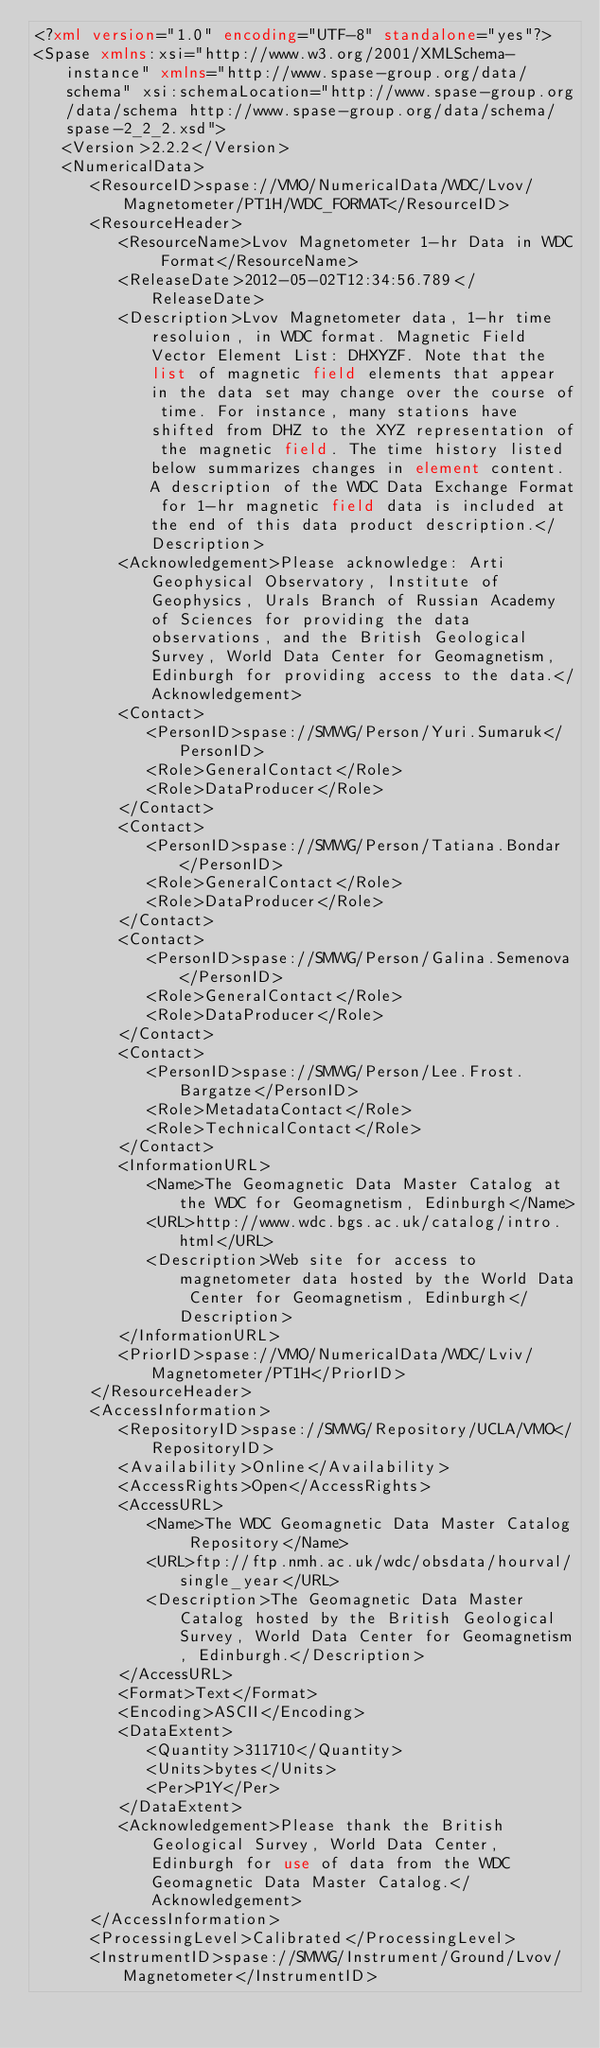<code> <loc_0><loc_0><loc_500><loc_500><_XML_><?xml version="1.0" encoding="UTF-8" standalone="yes"?>
<Spase xmlns:xsi="http://www.w3.org/2001/XMLSchema-instance" xmlns="http://www.spase-group.org/data/schema" xsi:schemaLocation="http://www.spase-group.org/data/schema http://www.spase-group.org/data/schema/spase-2_2_2.xsd">
   <Version>2.2.2</Version>
   <NumericalData>
      <ResourceID>spase://VMO/NumericalData/WDC/Lvov/Magnetometer/PT1H/WDC_FORMAT</ResourceID>
      <ResourceHeader>
         <ResourceName>Lvov Magnetometer 1-hr Data in WDC Format</ResourceName>
         <ReleaseDate>2012-05-02T12:34:56.789</ReleaseDate>
         <Description>Lvov Magnetometer data, 1-hr time resoluion, in WDC format. Magnetic Field Vector Element List: DHXYZF. Note that the list of magnetic field elements that appear in the data set may change over the course of time. For instance, many stations have shifted from DHZ to the XYZ representation of the magnetic field. The time history listed below summarizes changes in element content. A description of the WDC Data Exchange Format for 1-hr magnetic field data is included at the end of this data product description.</Description>
         <Acknowledgement>Please acknowledge: Arti Geophysical Observatory, Institute of Geophysics, Urals Branch of Russian Academy of Sciences for providing the data observations, and the British Geological Survey, World Data Center for Geomagnetism, Edinburgh for providing access to the data.</Acknowledgement>
         <Contact>
            <PersonID>spase://SMWG/Person/Yuri.Sumaruk</PersonID>
            <Role>GeneralContact</Role>
            <Role>DataProducer</Role>
         </Contact>
         <Contact>
            <PersonID>spase://SMWG/Person/Tatiana.Bondar</PersonID>
            <Role>GeneralContact</Role>
            <Role>DataProducer</Role>
         </Contact>
         <Contact>
            <PersonID>spase://SMWG/Person/Galina.Semenova</PersonID>
            <Role>GeneralContact</Role>
            <Role>DataProducer</Role>
         </Contact>
         <Contact>
            <PersonID>spase://SMWG/Person/Lee.Frost.Bargatze</PersonID>
            <Role>MetadataContact</Role>
            <Role>TechnicalContact</Role>
         </Contact>
         <InformationURL>
            <Name>The Geomagnetic Data Master Catalog at the WDC for Geomagnetism, Edinburgh</Name>
            <URL>http://www.wdc.bgs.ac.uk/catalog/intro.html</URL>
            <Description>Web site for access to magnetometer data hosted by the World Data Center for Geomagnetism, Edinburgh</Description>
         </InformationURL>
         <PriorID>spase://VMO/NumericalData/WDC/Lviv/Magnetometer/PT1H</PriorID>
      </ResourceHeader>
      <AccessInformation>
         <RepositoryID>spase://SMWG/Repository/UCLA/VMO</RepositoryID>
         <Availability>Online</Availability>
         <AccessRights>Open</AccessRights>
         <AccessURL>
            <Name>The WDC Geomagnetic Data Master Catalog Repository</Name>
            <URL>ftp://ftp.nmh.ac.uk/wdc/obsdata/hourval/single_year</URL>
            <Description>The Geomagnetic Data Master Catalog hosted by the British Geological Survey, World Data Center for Geomagnetism, Edinburgh.</Description>
         </AccessURL>
         <Format>Text</Format>
         <Encoding>ASCII</Encoding>
         <DataExtent>
            <Quantity>311710</Quantity>
            <Units>bytes</Units>
            <Per>P1Y</Per>
         </DataExtent>
         <Acknowledgement>Please thank the British Geological Survey, World Data Center, Edinburgh for use of data from the WDC Geomagnetic Data Master Catalog.</Acknowledgement>
      </AccessInformation>
      <ProcessingLevel>Calibrated</ProcessingLevel>
      <InstrumentID>spase://SMWG/Instrument/Ground/Lvov/Magnetometer</InstrumentID></code> 